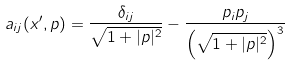<formula> <loc_0><loc_0><loc_500><loc_500>a _ { i j } ( x ^ { \prime } , p ) = \frac { \delta _ { i j } } { \sqrt { 1 + | p | ^ { 2 } } } - \frac { p _ { i } p _ { j } } { \left ( \sqrt { 1 + | p | ^ { 2 } } \right ) ^ { 3 } }</formula> 